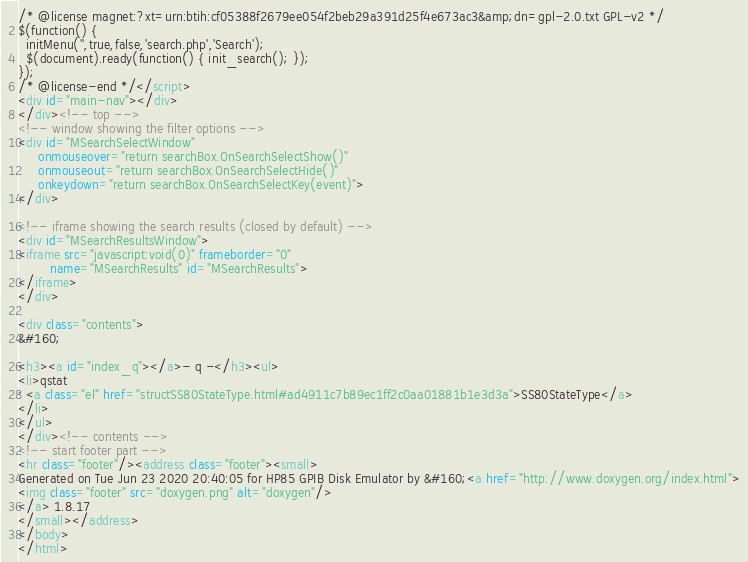Convert code to text. <code><loc_0><loc_0><loc_500><loc_500><_HTML_>/* @license magnet:?xt=urn:btih:cf05388f2679ee054f2beb29a391d25f4e673ac3&amp;dn=gpl-2.0.txt GPL-v2 */
$(function() {
  initMenu('',true,false,'search.php','Search');
  $(document).ready(function() { init_search(); });
});
/* @license-end */</script>
<div id="main-nav"></div>
</div><!-- top -->
<!-- window showing the filter options -->
<div id="MSearchSelectWindow"
     onmouseover="return searchBox.OnSearchSelectShow()"
     onmouseout="return searchBox.OnSearchSelectHide()"
     onkeydown="return searchBox.OnSearchSelectKey(event)">
</div>

<!-- iframe showing the search results (closed by default) -->
<div id="MSearchResultsWindow">
<iframe src="javascript:void(0)" frameborder="0" 
        name="MSearchResults" id="MSearchResults">
</iframe>
</div>

<div class="contents">
&#160;

<h3><a id="index_q"></a>- q -</h3><ul>
<li>qstat
: <a class="el" href="structSS80StateType.html#ad4911c7b89ec1ff2c0aa01881b1e3d3a">SS80StateType</a>
</li>
</ul>
</div><!-- contents -->
<!-- start footer part -->
<hr class="footer"/><address class="footer"><small>
Generated on Tue Jun 23 2020 20:40:05 for HP85 GPIB Disk Emulator by &#160;<a href="http://www.doxygen.org/index.html">
<img class="footer" src="doxygen.png" alt="doxygen"/>
</a> 1.8.17
</small></address>
</body>
</html>
</code> 